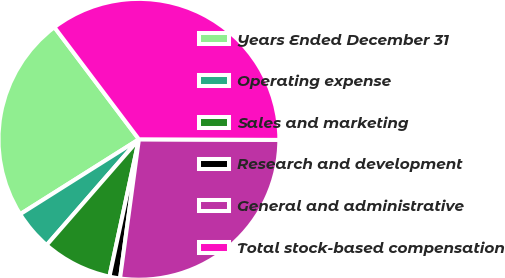Convert chart to OTSL. <chart><loc_0><loc_0><loc_500><loc_500><pie_chart><fcel>Years Ended December 31<fcel>Operating expense<fcel>Sales and marketing<fcel>Research and development<fcel>General and administrative<fcel>Total stock-based compensation<nl><fcel>23.67%<fcel>4.63%<fcel>8.05%<fcel>1.22%<fcel>27.08%<fcel>35.35%<nl></chart> 